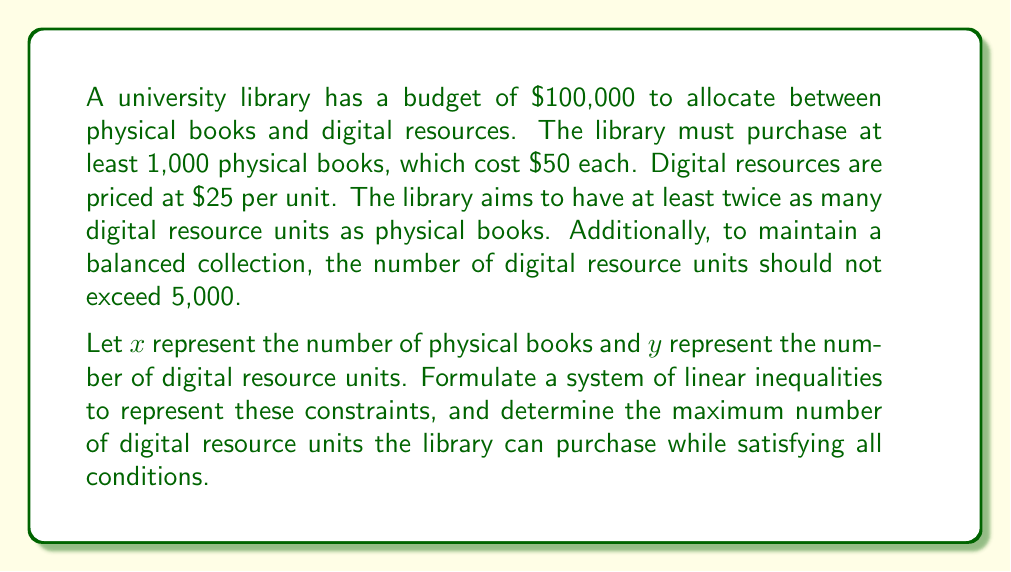Help me with this question. Let's approach this step-by-step:

1. Translate the given information into inequalities:
   a. Budget constraint: $50x + 25y \leq 100000$
   b. Minimum number of physical books: $x \geq 1000$
   c. Digital resources should be at least twice the physical books: $y \geq 2x$
   d. Maximum number of digital resources: $y \leq 5000$

2. Simplify the budget constraint:
   $50x + 25y \leq 100000$
   $2x + y \leq 4000$ (dividing both sides by 25)

3. Our system of inequalities is now:
   $$\begin{cases}
   2x + y \leq 4000 \\
   x \geq 1000 \\
   y \geq 2x \\
   y \leq 5000
   \end{cases}$$

4. To maximize $y$, we need to minimize $x$ while satisfying all constraints. The minimum value for $x$ is 1000.

5. Substitute $x = 1000$ into $y \geq 2x$:
   $y \geq 2(1000) = 2000$

6. Now, check the budget constraint with $x = 1000$:
   $2(1000) + y \leq 4000$
   $2000 + y \leq 4000$
   $y \leq 2000$

7. The upper bound for $y$ is the minimum of:
   a. $y \leq 2000$ (from budget constraint)
   b. $y \leq 5000$ (from original constraint)

Therefore, the maximum value for $y$ is 2000.
Answer: The maximum number of digital resource units the library can purchase while satisfying all conditions is 2000. 